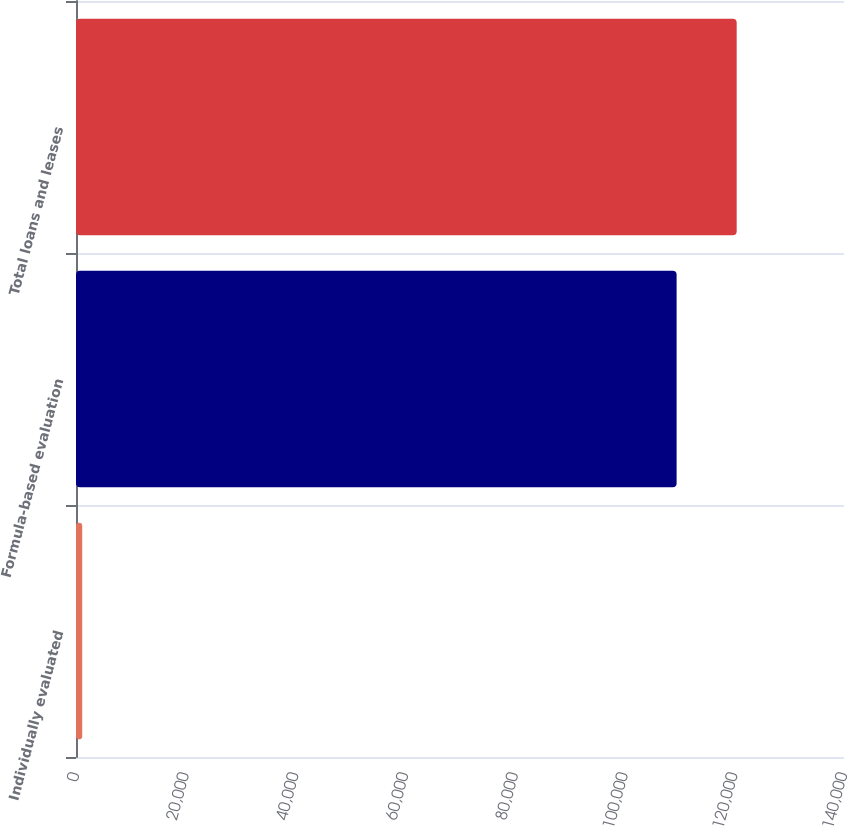Convert chart to OTSL. <chart><loc_0><loc_0><loc_500><loc_500><bar_chart><fcel>Individually evaluated<fcel>Formula-based evaluation<fcel>Total loans and leases<nl><fcel>1131<fcel>109486<fcel>120435<nl></chart> 